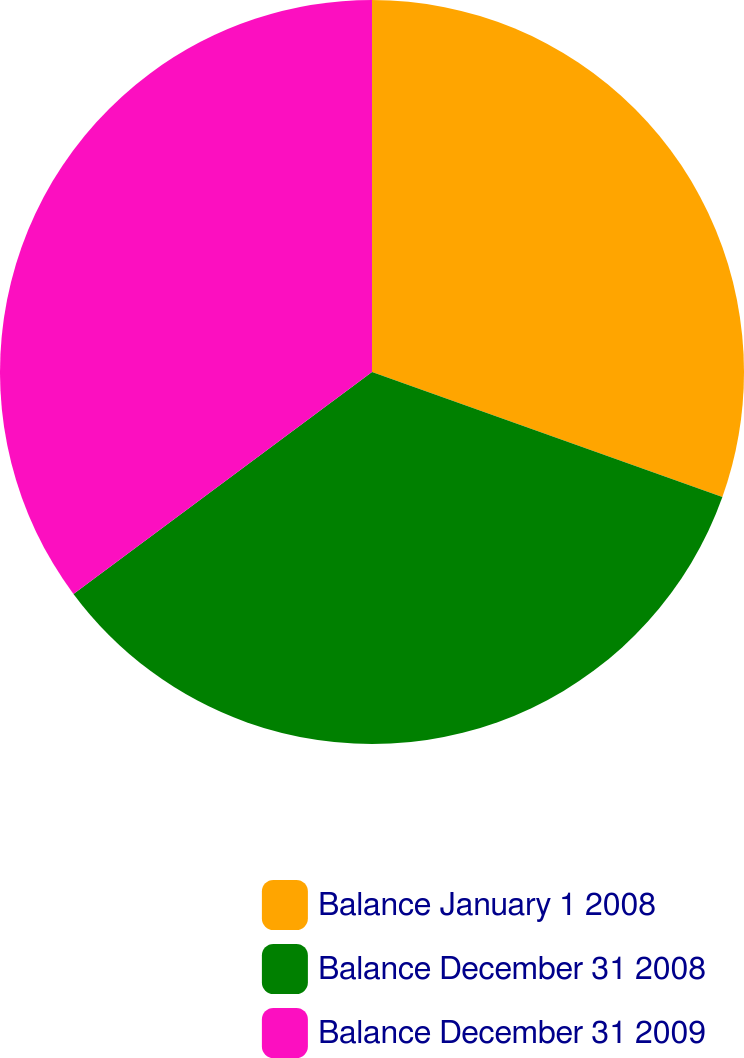Convert chart to OTSL. <chart><loc_0><loc_0><loc_500><loc_500><pie_chart><fcel>Balance January 1 2008<fcel>Balance December 31 2008<fcel>Balance December 31 2009<nl><fcel>30.45%<fcel>34.37%<fcel>35.17%<nl></chart> 